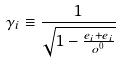<formula> <loc_0><loc_0><loc_500><loc_500>\gamma _ { i } \equiv \frac { 1 } { \sqrt { 1 - \frac { e _ { i } + e _ { i } } { o ^ { 0 } } } }</formula> 